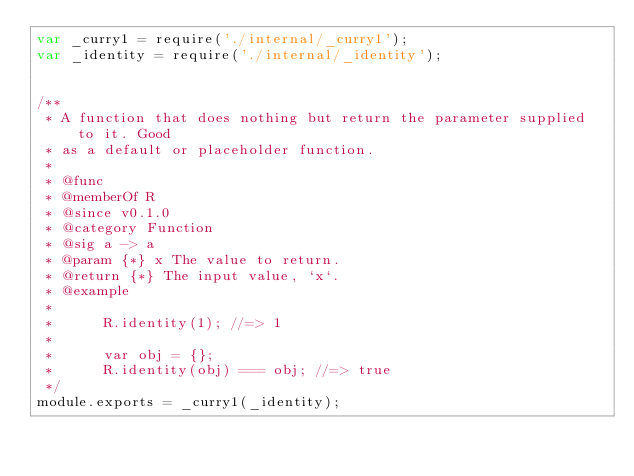Convert code to text. <code><loc_0><loc_0><loc_500><loc_500><_JavaScript_>var _curry1 = require('./internal/_curry1');
var _identity = require('./internal/_identity');


/**
 * A function that does nothing but return the parameter supplied to it. Good
 * as a default or placeholder function.
 *
 * @func
 * @memberOf R
 * @since v0.1.0
 * @category Function
 * @sig a -> a
 * @param {*} x The value to return.
 * @return {*} The input value, `x`.
 * @example
 *
 *      R.identity(1); //=> 1
 *
 *      var obj = {};
 *      R.identity(obj) === obj; //=> true
 */
module.exports = _curry1(_identity);
</code> 